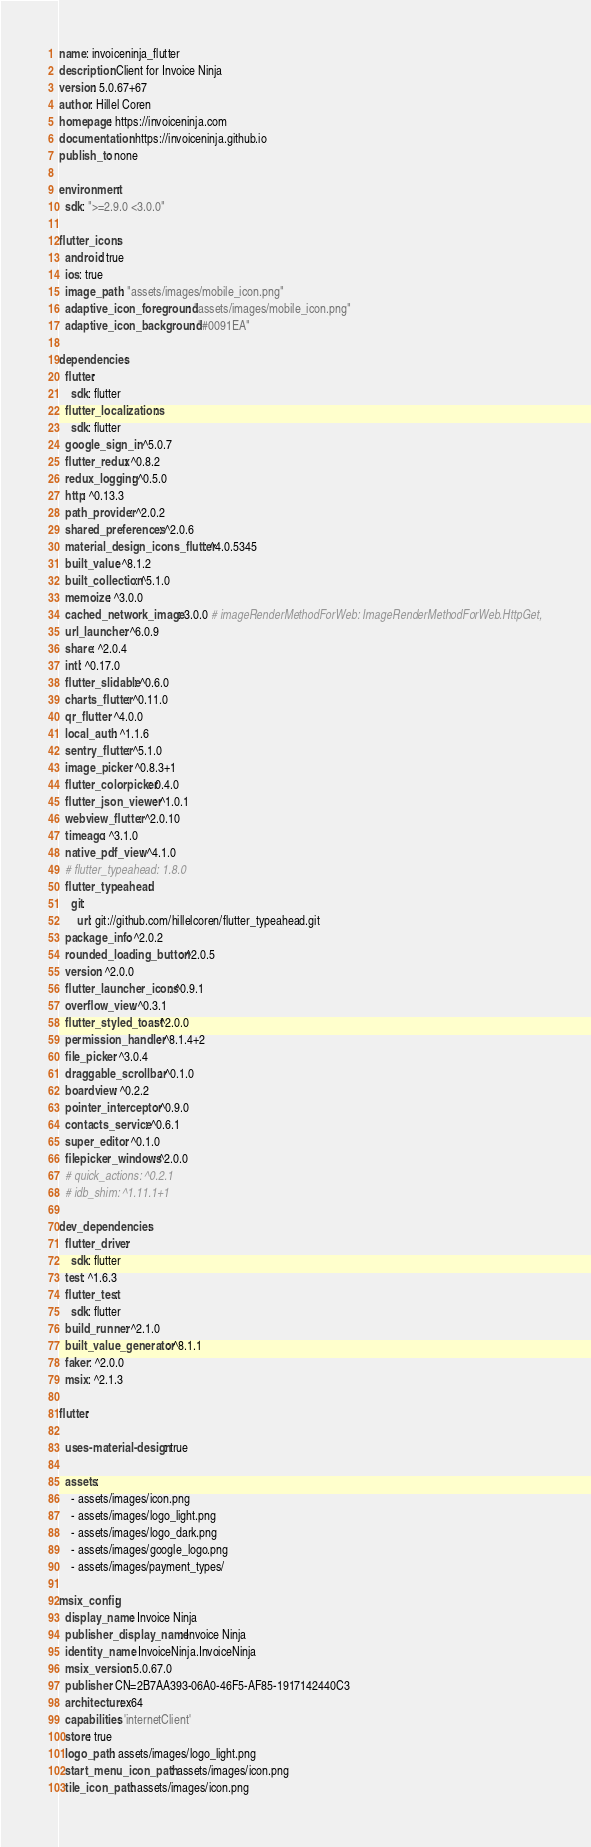<code> <loc_0><loc_0><loc_500><loc_500><_YAML_>name: invoiceninja_flutter
description: Client for Invoice Ninja
version: 5.0.67+67
author: Hillel Coren
homepage: https://invoiceninja.com
documentation: https://invoiceninja.github.io
publish_to: none

environment:
  sdk: ">=2.9.0 <3.0.0"

flutter_icons:
  android: true
  ios: true
  image_path: "assets/images/mobile_icon.png"
  adaptive_icon_foreground: "assets/images/mobile_icon.png"
  adaptive_icon_background: "#0091EA"

dependencies:
  flutter:
    sdk: flutter
  flutter_localizations:
    sdk: flutter
  google_sign_in: ^5.0.7
  flutter_redux: ^0.8.2
  redux_logging: ^0.5.0
  http: ^0.13.3
  path_provider: ^2.0.2
  shared_preferences: ^2.0.6
  material_design_icons_flutter: ^4.0.5345
  built_value: ^8.1.2
  built_collection: ^5.1.0
  memoize: ^3.0.0
  cached_network_image: 3.0.0 # imageRenderMethodForWeb: ImageRenderMethodForWeb.HttpGet,
  url_launcher: ^6.0.9
  share: ^2.0.4
  intl: ^0.17.0
  flutter_slidable: ^0.6.0
  charts_flutter: ^0.11.0
  qr_flutter: ^4.0.0
  local_auth: ^1.1.6
  sentry_flutter: ^5.1.0
  image_picker: ^0.8.3+1
  flutter_colorpicker: 0.4.0
  flutter_json_viewer: ^1.0.1
  webview_flutter: ^2.0.10
  timeago: ^3.1.0
  native_pdf_view: ^4.1.0
  # flutter_typeahead: 1.8.0
  flutter_typeahead:
    git:
      url: git://github.com/hillelcoren/flutter_typeahead.git
  package_info: ^2.0.2
  rounded_loading_button: ^2.0.5
  version: ^2.0.0
  flutter_launcher_icons: ^0.9.1
  overflow_view: ^0.3.1
  flutter_styled_toast: ^2.0.0
  permission_handler: ^8.1.4+2
  file_picker: ^3.0.4
  draggable_scrollbar: ^0.1.0
  boardview: ^0.2.2
  pointer_interceptor: ^0.9.0
  contacts_service: ^0.6.1
  super_editor: ^0.1.0
  filepicker_windows: ^2.0.0
  # quick_actions: ^0.2.1
  # idb_shim: ^1.11.1+1

dev_dependencies:
  flutter_driver:
    sdk: flutter
  test: ^1.6.3
  flutter_test:
    sdk: flutter
  build_runner: ^2.1.0
  built_value_generator: ^8.1.1
  faker: ^2.0.0
  msix: ^2.1.3

flutter:

  uses-material-design: true

  assets:
    - assets/images/icon.png
    - assets/images/logo_light.png
    - assets/images/logo_dark.png
    - assets/images/google_logo.png
    - assets/images/payment_types/

msix_config:
  display_name: Invoice Ninja
  publisher_display_name: Invoice Ninja
  identity_name: InvoiceNinja.InvoiceNinja
  msix_version: 5.0.67.0
  publisher: CN=2B7AA393-06A0-46F5-AF85-1917142440C3
  architecture: x64
  capabilities: 'internetClient'
  store: true
  logo_path: assets/images/logo_light.png
  start_menu_icon_path: assets/images/icon.png
  tile_icon_path: assets/images/icon.png</code> 